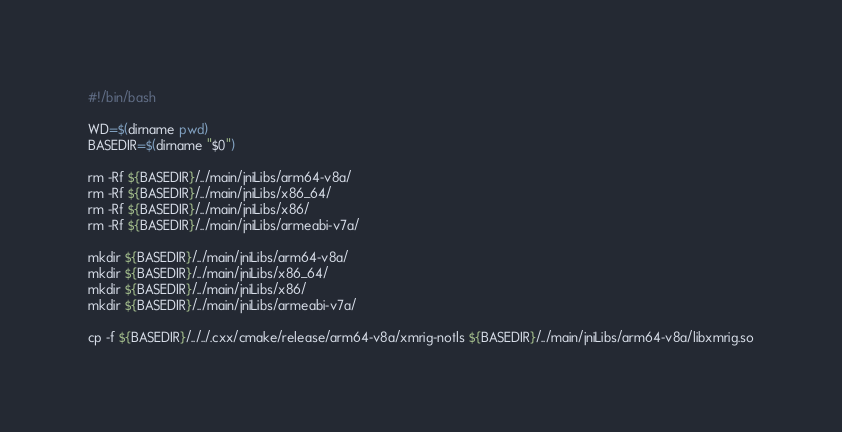Convert code to text. <code><loc_0><loc_0><loc_500><loc_500><_Bash_>#!/bin/bash

WD=$(dirname pwd)
BASEDIR=$(dirname "$0")

rm -Rf ${BASEDIR}/../main/jniLibs/arm64-v8a/
rm -Rf ${BASEDIR}/../main/jniLibs/x86_64/
rm -Rf ${BASEDIR}/../main/jniLibs/x86/
rm -Rf ${BASEDIR}/../main/jniLibs/armeabi-v7a/

mkdir ${BASEDIR}/../main/jniLibs/arm64-v8a/
mkdir ${BASEDIR}/../main/jniLibs/x86_64/
mkdir ${BASEDIR}/../main/jniLibs/x86/
mkdir ${BASEDIR}/../main/jniLibs/armeabi-v7a/

cp -f ${BASEDIR}/../../.cxx/cmake/release/arm64-v8a/xmrig-notls ${BASEDIR}/../main/jniLibs/arm64-v8a/libxmrig.so</code> 